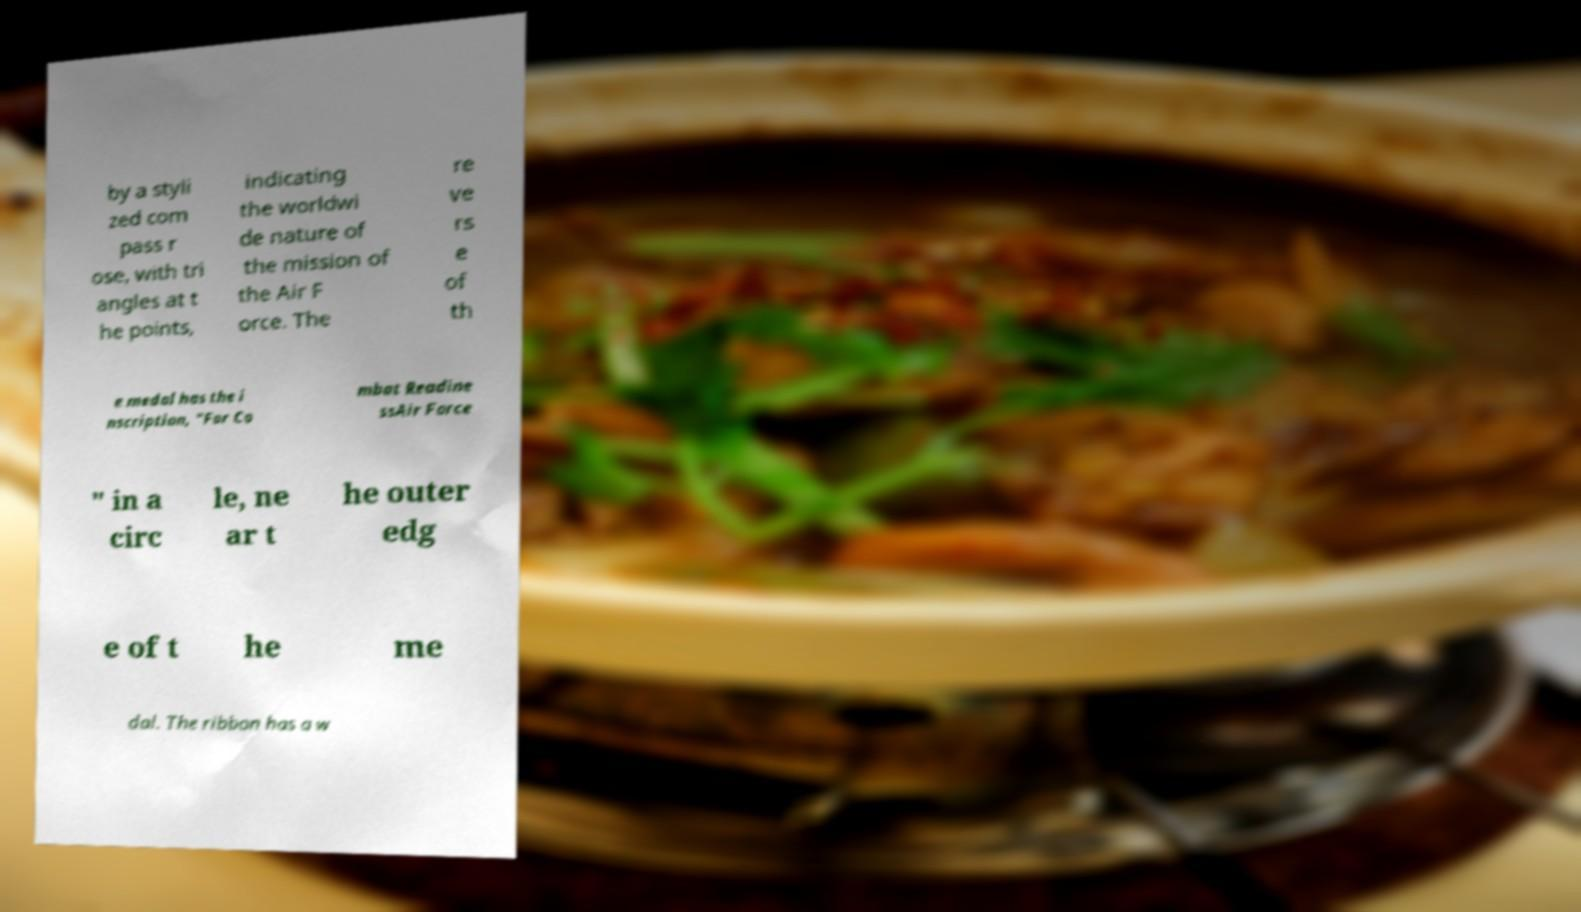Please identify and transcribe the text found in this image. by a styli zed com pass r ose, with tri angles at t he points, indicating the worldwi de nature of the mission of the Air F orce. The re ve rs e of th e medal has the i nscription, "For Co mbat Readine ssAir Force " in a circ le, ne ar t he outer edg e of t he me dal. The ribbon has a w 